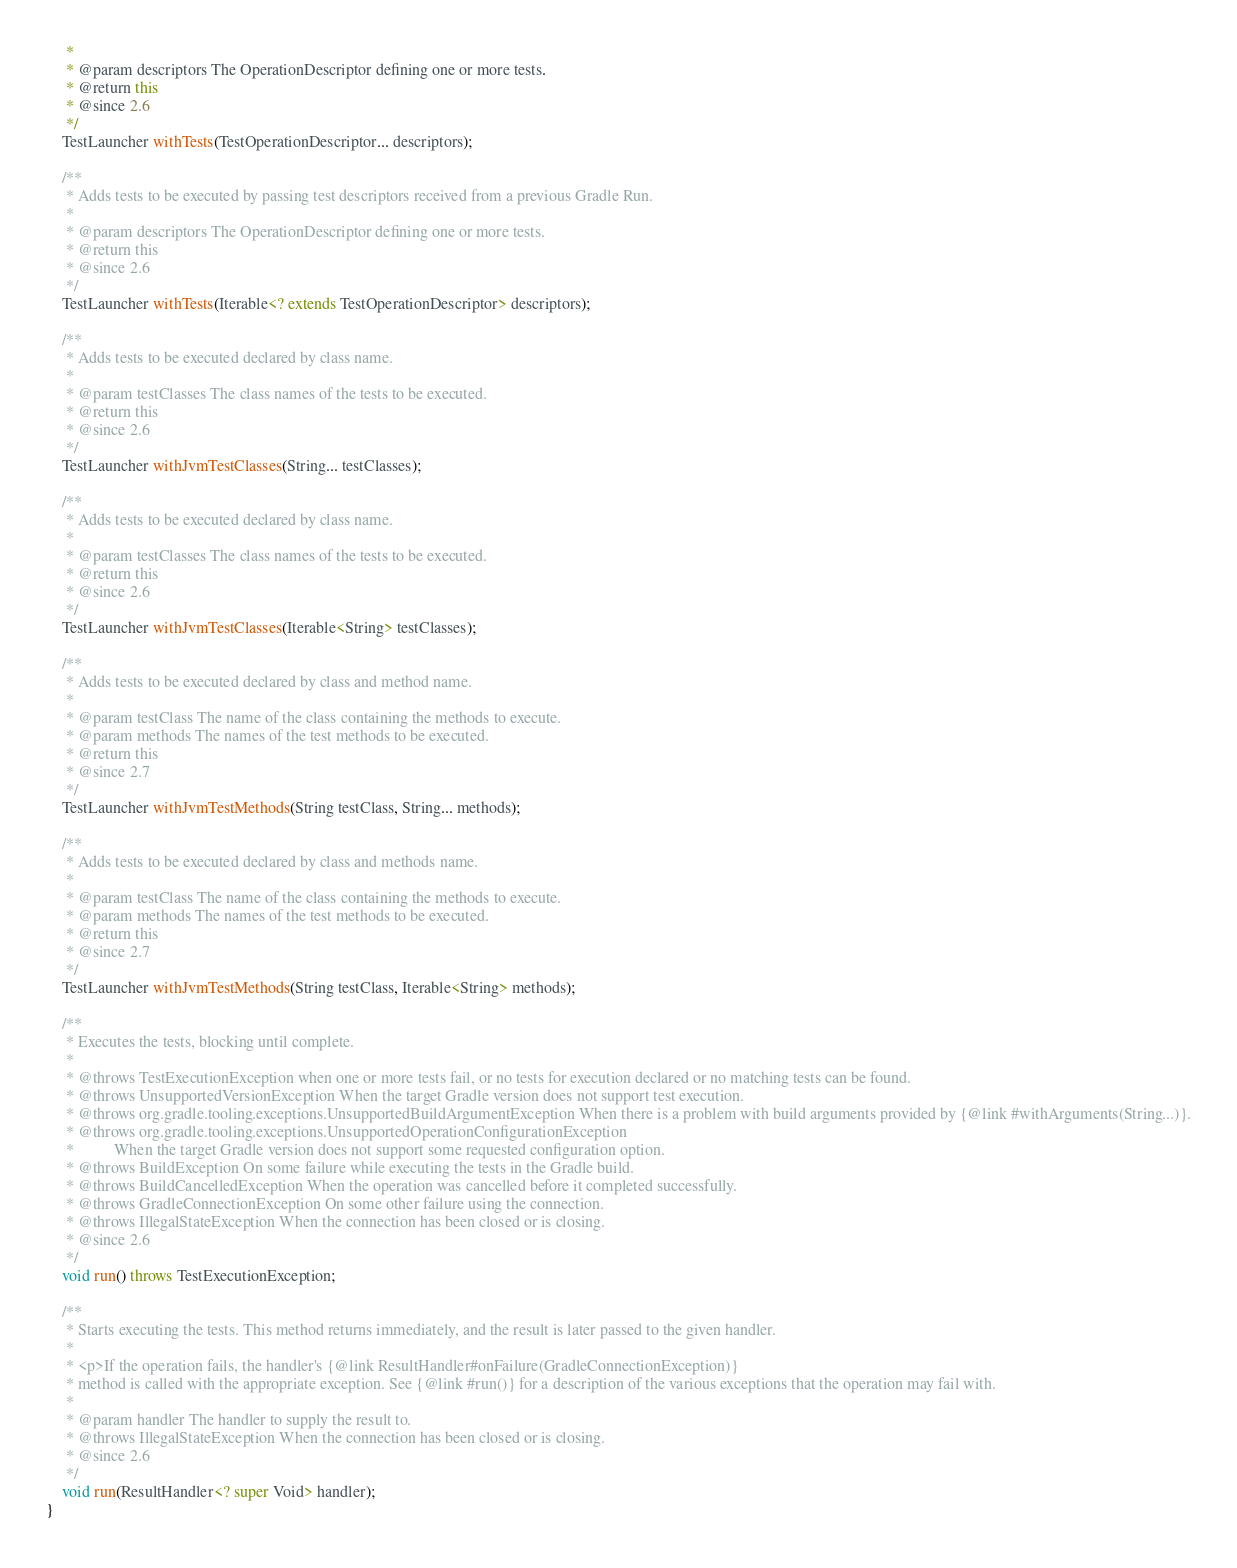Convert code to text. <code><loc_0><loc_0><loc_500><loc_500><_Java_>     *
     * @param descriptors The OperationDescriptor defining one or more tests.
     * @return this
     * @since 2.6
     */
    TestLauncher withTests(TestOperationDescriptor... descriptors);

    /**
     * Adds tests to be executed by passing test descriptors received from a previous Gradle Run.
     *
     * @param descriptors The OperationDescriptor defining one or more tests.
     * @return this
     * @since 2.6
     */
    TestLauncher withTests(Iterable<? extends TestOperationDescriptor> descriptors);

    /**
     * Adds tests to be executed declared by class name.
     *
     * @param testClasses The class names of the tests to be executed.
     * @return this
     * @since 2.6
     */
    TestLauncher withJvmTestClasses(String... testClasses);

    /**
     * Adds tests to be executed declared by class name.
     *
     * @param testClasses The class names of the tests to be executed.
     * @return this
     * @since 2.6
     */
    TestLauncher withJvmTestClasses(Iterable<String> testClasses);

    /**
     * Adds tests to be executed declared by class and method name.
     *
     * @param testClass The name of the class containing the methods to execute.
     * @param methods The names of the test methods to be executed.
     * @return this
     * @since 2.7
     */
    TestLauncher withJvmTestMethods(String testClass, String... methods);

    /**
     * Adds tests to be executed declared by class and methods name.
     *
     * @param testClass The name of the class containing the methods to execute.
     * @param methods The names of the test methods to be executed.
     * @return this
     * @since 2.7
     */
    TestLauncher withJvmTestMethods(String testClass, Iterable<String> methods);

    /**
     * Executes the tests, blocking until complete.
     *
     * @throws TestExecutionException when one or more tests fail, or no tests for execution declared or no matching tests can be found.
     * @throws UnsupportedVersionException When the target Gradle version does not support test execution.
     * @throws org.gradle.tooling.exceptions.UnsupportedBuildArgumentException When there is a problem with build arguments provided by {@link #withArguments(String...)}.
     * @throws org.gradle.tooling.exceptions.UnsupportedOperationConfigurationException
     *          When the target Gradle version does not support some requested configuration option.
     * @throws BuildException On some failure while executing the tests in the Gradle build.
     * @throws BuildCancelledException When the operation was cancelled before it completed successfully.
     * @throws GradleConnectionException On some other failure using the connection.
     * @throws IllegalStateException When the connection has been closed or is closing.
     * @since 2.6
     */
    void run() throws TestExecutionException;

    /**
     * Starts executing the tests. This method returns immediately, and the result is later passed to the given handler.
     *
     * <p>If the operation fails, the handler's {@link ResultHandler#onFailure(GradleConnectionException)}
     * method is called with the appropriate exception. See {@link #run()} for a description of the various exceptions that the operation may fail with.
     *
     * @param handler The handler to supply the result to.
     * @throws IllegalStateException When the connection has been closed or is closing.
     * @since 2.6
     */
    void run(ResultHandler<? super Void> handler);
}
</code> 